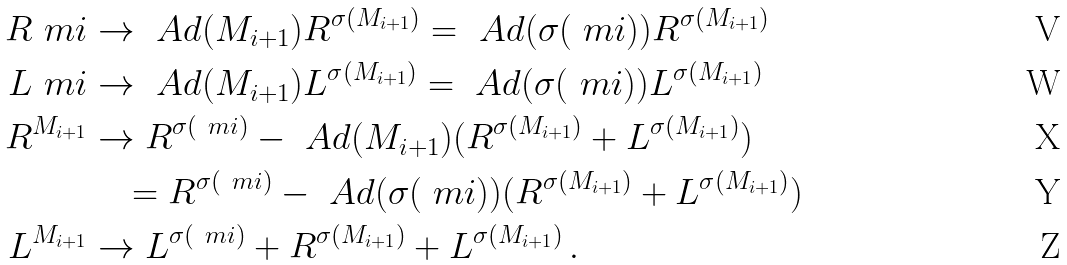Convert formula to latex. <formula><loc_0><loc_0><loc_500><loc_500>R ^ { \ } m i & \rightarrow \ A d ( M _ { i + 1 } ) R ^ { \sigma ( M _ { i + 1 } ) } = \ A d ( \sigma ( \ m i ) ) R ^ { \sigma ( M _ { i + 1 } ) } \\ L ^ { \ } m i & \rightarrow \ A d ( M _ { i + 1 } ) L ^ { \sigma ( M _ { i + 1 } ) } = \ A d ( \sigma ( \ m i ) ) L ^ { \sigma ( M _ { i + 1 } ) } \\ R ^ { M _ { i + 1 } } & \rightarrow R ^ { \sigma ( \ m i ) } - \ A d ( M _ { i + 1 } ) ( R ^ { \sigma ( M _ { i + 1 } ) } + L ^ { \sigma ( M _ { i + 1 } ) } ) \\ & \quad = R ^ { \sigma ( \ m i ) } - \ A d ( \sigma ( \ m i ) ) ( R ^ { \sigma ( M _ { i + 1 } ) } + L ^ { \sigma ( M _ { i + 1 } ) } ) \\ L ^ { M _ { i + 1 } } & \rightarrow L ^ { \sigma ( \ m i ) } + R ^ { \sigma ( M _ { i + 1 } ) } + L ^ { \sigma ( M _ { i + 1 } ) } \, .</formula> 